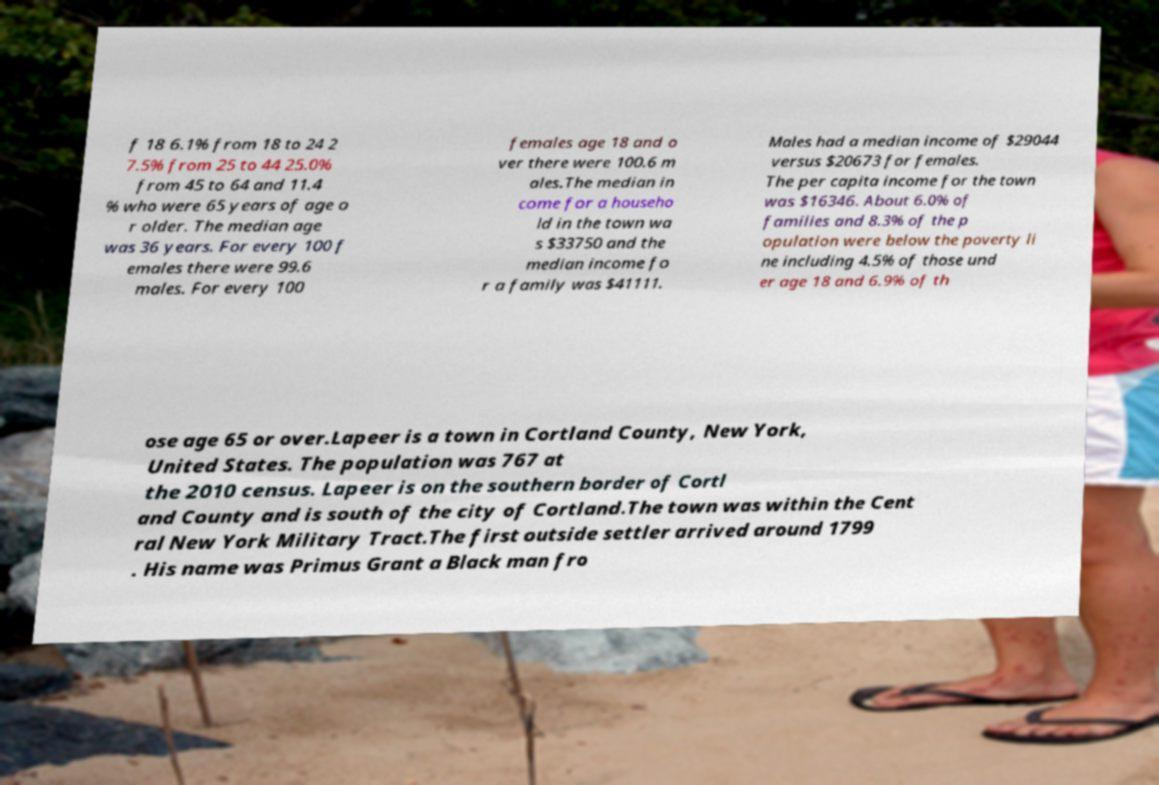There's text embedded in this image that I need extracted. Can you transcribe it verbatim? f 18 6.1% from 18 to 24 2 7.5% from 25 to 44 25.0% from 45 to 64 and 11.4 % who were 65 years of age o r older. The median age was 36 years. For every 100 f emales there were 99.6 males. For every 100 females age 18 and o ver there were 100.6 m ales.The median in come for a househo ld in the town wa s $33750 and the median income fo r a family was $41111. Males had a median income of $29044 versus $20673 for females. The per capita income for the town was $16346. About 6.0% of families and 8.3% of the p opulation were below the poverty li ne including 4.5% of those und er age 18 and 6.9% of th ose age 65 or over.Lapeer is a town in Cortland County, New York, United States. The population was 767 at the 2010 census. Lapeer is on the southern border of Cortl and County and is south of the city of Cortland.The town was within the Cent ral New York Military Tract.The first outside settler arrived around 1799 . His name was Primus Grant a Black man fro 